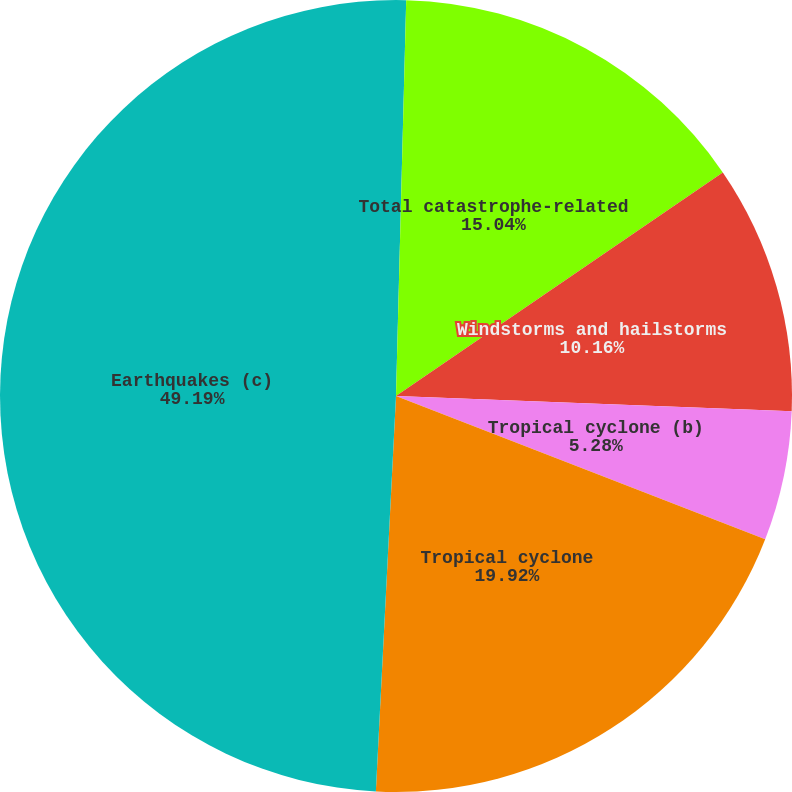Convert chart to OTSL. <chart><loc_0><loc_0><loc_500><loc_500><pie_chart><fcel>Flooding<fcel>Total catastrophe-related<fcel>Windstorms and hailstorms<fcel>Tropical cyclone (b)<fcel>Tropical cyclone<fcel>Earthquakes (c)<nl><fcel>0.41%<fcel>15.04%<fcel>10.16%<fcel>5.28%<fcel>19.92%<fcel>49.19%<nl></chart> 